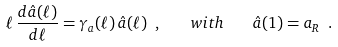<formula> <loc_0><loc_0><loc_500><loc_500>\ell \, \frac { d { \hat { a } } ( \ell ) } { d \ell } = \gamma _ { a } ( \ell ) \, { \hat { a } } ( \ell ) \ , \quad w i t h \quad \hat { a } ( 1 ) = a _ { R } \ .</formula> 